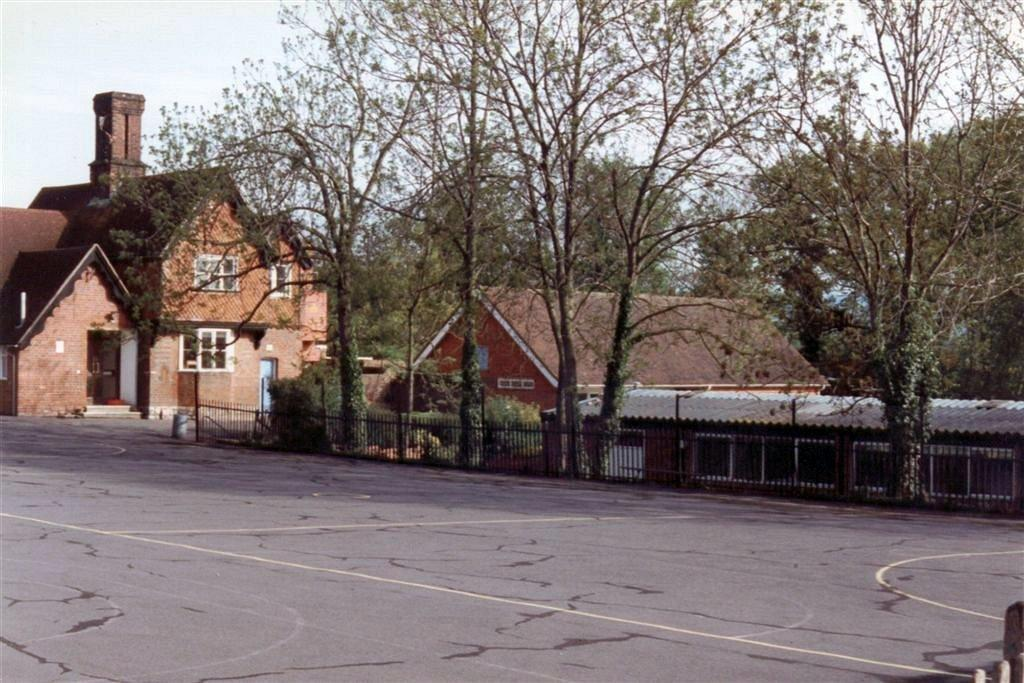What type of pathway is visible in the image? There is a road in the image. What kind of barrier is present alongside the road? There is a metal rod fence in the image. What type of vegetation can be seen in the image? There are bushes and trees in the image. What type of structures are visible in the image? There are houses in the image. What game is being played by the son in the image? There is no son or game present in the image. What activity is the son participating in with his friends in the image? There is no son or friends present in the image. 